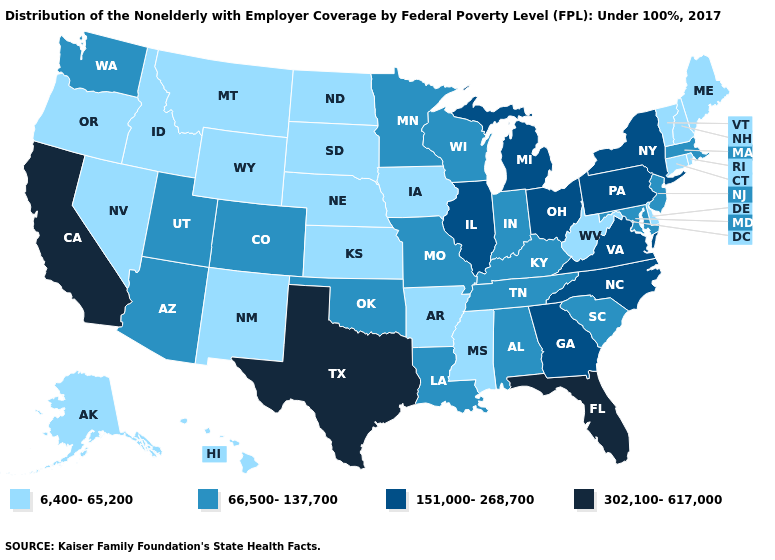What is the value of Florida?
Keep it brief. 302,100-617,000. Among the states that border Tennessee , which have the highest value?
Quick response, please. Georgia, North Carolina, Virginia. Which states have the lowest value in the West?
Write a very short answer. Alaska, Hawaii, Idaho, Montana, Nevada, New Mexico, Oregon, Wyoming. Name the states that have a value in the range 151,000-268,700?
Be succinct. Georgia, Illinois, Michigan, New York, North Carolina, Ohio, Pennsylvania, Virginia. Among the states that border North Dakota , which have the highest value?
Be succinct. Minnesota. Name the states that have a value in the range 6,400-65,200?
Short answer required. Alaska, Arkansas, Connecticut, Delaware, Hawaii, Idaho, Iowa, Kansas, Maine, Mississippi, Montana, Nebraska, Nevada, New Hampshire, New Mexico, North Dakota, Oregon, Rhode Island, South Dakota, Vermont, West Virginia, Wyoming. Name the states that have a value in the range 6,400-65,200?
Quick response, please. Alaska, Arkansas, Connecticut, Delaware, Hawaii, Idaho, Iowa, Kansas, Maine, Mississippi, Montana, Nebraska, Nevada, New Hampshire, New Mexico, North Dakota, Oregon, Rhode Island, South Dakota, Vermont, West Virginia, Wyoming. What is the lowest value in the MidWest?
Short answer required. 6,400-65,200. What is the value of Florida?
Write a very short answer. 302,100-617,000. Does Iowa have a lower value than Arkansas?
Keep it brief. No. Name the states that have a value in the range 6,400-65,200?
Answer briefly. Alaska, Arkansas, Connecticut, Delaware, Hawaii, Idaho, Iowa, Kansas, Maine, Mississippi, Montana, Nebraska, Nevada, New Hampshire, New Mexico, North Dakota, Oregon, Rhode Island, South Dakota, Vermont, West Virginia, Wyoming. Name the states that have a value in the range 66,500-137,700?
Short answer required. Alabama, Arizona, Colorado, Indiana, Kentucky, Louisiana, Maryland, Massachusetts, Minnesota, Missouri, New Jersey, Oklahoma, South Carolina, Tennessee, Utah, Washington, Wisconsin. Among the states that border Indiana , which have the highest value?
Short answer required. Illinois, Michigan, Ohio. Is the legend a continuous bar?
Write a very short answer. No. What is the highest value in the West ?
Write a very short answer. 302,100-617,000. 